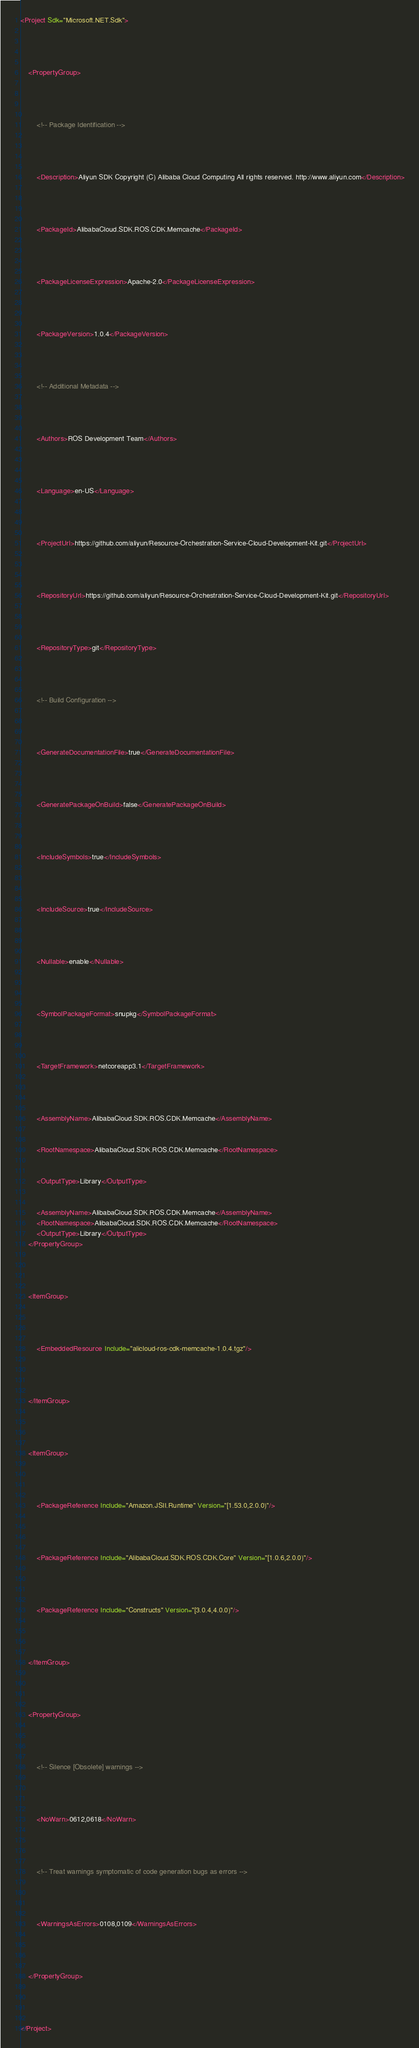Convert code to text. <code><loc_0><loc_0><loc_500><loc_500><_XML_><Project Sdk="Microsoft.NET.Sdk">
	
	
  
	
	<PropertyGroup>
		
		
    
		
		<!-- Package Identification -->
		
		
    
		
		<Description>Aliyun SDK Copyright (C) Alibaba Cloud Computing All rights reserved. http://www.aliyun.com</Description>
		
		
    
		
		<PackageId>AlibabaCloud.SDK.ROS.CDK.Memcache</PackageId>
		
		
    
		
		<PackageLicenseExpression>Apache-2.0</PackageLicenseExpression>
		
		
    
		
		<PackageVersion>1.0.4</PackageVersion>
		
		
    
		
		<!-- Additional Metadata -->
		
		
    
		
		<Authors>ROS Development Team</Authors>
		
		
    
		
		<Language>en-US</Language>
		
		
    
		
		<ProjectUrl>https://github.com/aliyun/Resource-Orchestration-Service-Cloud-Development-Kit.git</ProjectUrl>
		
		
    
		
		<RepositoryUrl>https://github.com/aliyun/Resource-Orchestration-Service-Cloud-Development-Kit.git</RepositoryUrl>
		
		
    
		
		<RepositoryType>git</RepositoryType>
		
		
    
		
		<!-- Build Configuration -->
		
		
    
		
		<GenerateDocumentationFile>true</GenerateDocumentationFile>
		
		
    
		
		<GeneratePackageOnBuild>false</GeneratePackageOnBuild>
		
		
    
		
		<IncludeSymbols>true</IncludeSymbols>
		
		
    
		
		<IncludeSource>true</IncludeSource>
		
		
    
		
		<Nullable>enable</Nullable>
		
		
    
		
		<SymbolPackageFormat>snupkg</SymbolPackageFormat>
		
		
    
		
		<TargetFramework>netcoreapp3.1</TargetFramework>
		
		
  
		
		<AssemblyName>AlibabaCloud.SDK.ROS.CDK.Memcache</AssemblyName>
		
		
		<RootNamespace>AlibabaCloud.SDK.ROS.CDK.Memcache</RootNamespace>
		
		
		<OutputType>Library</OutputType>
		
	
		<AssemblyName>AlibabaCloud.SDK.ROS.CDK.Memcache</AssemblyName>
		<RootNamespace>AlibabaCloud.SDK.ROS.CDK.Memcache</RootNamespace>
		<OutputType>Library</OutputType>
	</PropertyGroup>
	
	
  
	
	<ItemGroup>
		
		
    
		
		<EmbeddedResource Include="alicloud-ros-cdk-memcache-1.0.4.tgz"/>
		
		
  
	
	</ItemGroup>
	
	
  
	
	<ItemGroup>
		
		
    
		
		<PackageReference Include="Amazon.JSII.Runtime" Version="[1.53.0,2.0.0)"/>
		
		
    
		
		<PackageReference Include="AlibabaCloud.SDK.ROS.CDK.Core" Version="[1.0.6,2.0.0)"/>
		
		
    
		
		<PackageReference Include="Constructs" Version="[3.0.4,4.0.0)"/>
		
		
  
	
	</ItemGroup>
	
	
  
	
	<PropertyGroup>
		
		
    
		
		<!-- Silence [Obsolete] warnings -->
		
		
    
		
		<NoWarn>0612,0618</NoWarn>
		
		
    
		
		<!-- Treat warnings symptomatic of code generation bugs as errors -->
		
		
    
		
		<WarningsAsErrors>0108,0109</WarningsAsErrors>
		
		
  
	
	</PropertyGroup>
	
	


</Project>
</code> 